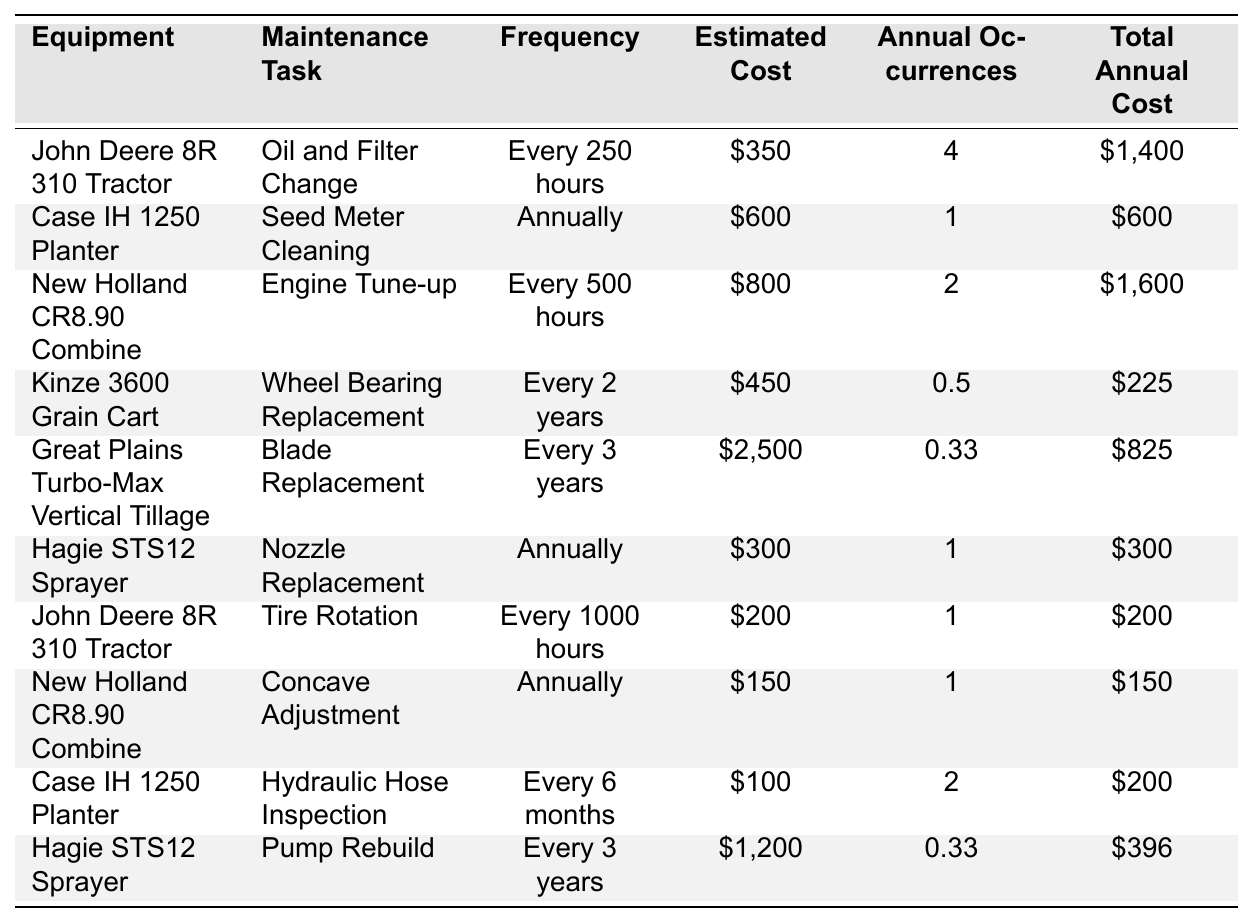What is the total annual cost for maintaining the John Deere 8R 310 Tractor? The table shows that the John Deere 8R 310 Tractor has two maintenance tasks: Oil and Filter Change with a total annual cost of $1,400 and Tire Rotation with a total annual cost of $200. So, the total annual cost is $1,400 + $200 = $1,600.
Answer: $1,600 How often does the Case IH 1250 Planter need a seed meter cleaning? According to the table, the Case IH 1250 Planter requires a seed meter cleaning annually.
Answer: Annually What is the estimated cost for a nozzle replacement on the Hagie STS12 Sprayer? The estimated cost for the nozzle replacement on the Hagie STS12 Sprayer is listed as $300 in the table.
Answer: $300 What is the total annual cost for all maintenance tasks associated with the New Holland CR8.90 Combine? The New Holland CR8.90 Combine has two maintenance tasks: Engine Tune-up with a total annual cost of $1,600 and Concave Adjustment with a total annual cost of $150. Therefore, the total annual cost is $1,600 + $150 = $1,750.
Answer: $1,750 Is the maintenance frequency for the Great Plains Turbo-Max Vertical Tillage every year? The table indicates that the maintenance task for Blade Replacement on the Great Plains Turbo-Max Vertical Tillage is every 3 years, not annually. Therefore, this statement is false.
Answer: No What is the frequency for hydraulic hose inspection on the Case IH 1250 Planter? The frequency for hydraulic hose inspection on the Case IH 1250 Planter is every 6 months according to the table.
Answer: Every 6 months Calculate the average total annual cost for all listed maintenance tasks. First, sum the total annual costs: $1,400 (Tractor) + $600 (Planter) + $1,600 (Combine) + $225 (Grain Cart) + $825 (Tillage) + $300 (Sprayer) + $200 (Tractor) + $150 (Combine) + $200 (Planter) + $396 (Sprayer) = $5,622. There are 10 maintenance tasks, so average cost is $5,622 / 10 = $562.20.
Answer: $562.20 Which equipment requires maintenance every 2 years? The table lists the Kinze 3600 Grain Cart, which needs wheel bearing replacement every 2 years.
Answer: Kinze 3600 Grain Cart What is the total estimated cost for the maintenance tasks scheduled every three years? The table shows the Great Plains Turbo-Max Vertical Tillage with a Blade Replacement cost of $2,500 and the Hagie STS12 Sprayer with a Pump Rebuild cost of $1,200. Therefore, total estimated cost is $2,500 + $1,200 = $3,700.
Answer: $3,700 Are any maintenance tasks scheduled for less than once a year? The Kinze 3600 Grain Cart’s wheel bearing replacement occurs every 2 years and the Great Plains Turbo-Max Tillage’s blade replacement happens every 3 years, both of which are less frequent than yearly. Therefore, yes, there are tasks scheduled for less than once a year.
Answer: Yes 